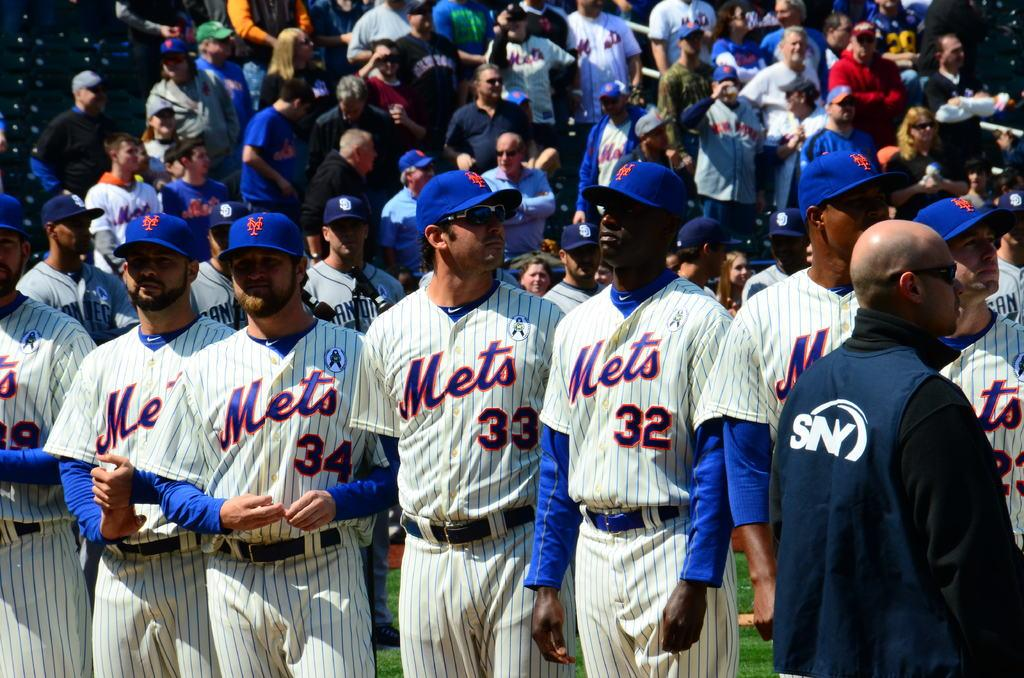<image>
Relay a brief, clear account of the picture shown. A line of baseball players are wearing Mets uniforms. 